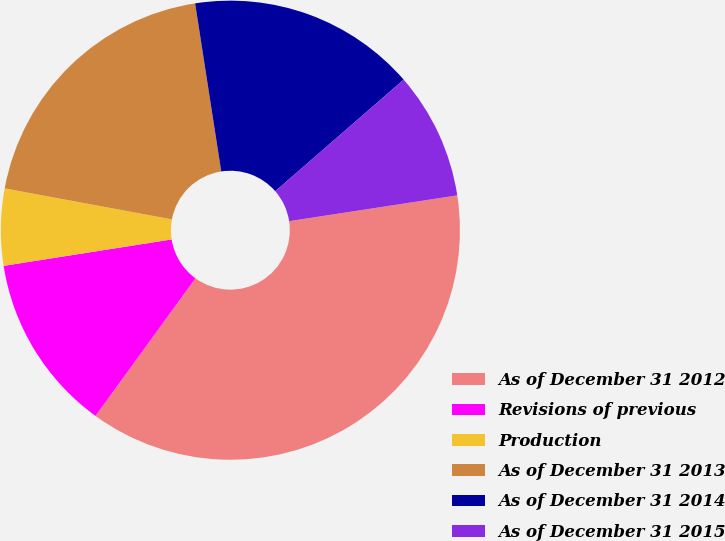Convert chart. <chart><loc_0><loc_0><loc_500><loc_500><pie_chart><fcel>As of December 31 2012<fcel>Revisions of previous<fcel>Production<fcel>As of December 31 2013<fcel>As of December 31 2014<fcel>As of December 31 2015<nl><fcel>37.42%<fcel>12.52%<fcel>5.4%<fcel>19.63%<fcel>16.07%<fcel>8.96%<nl></chart> 